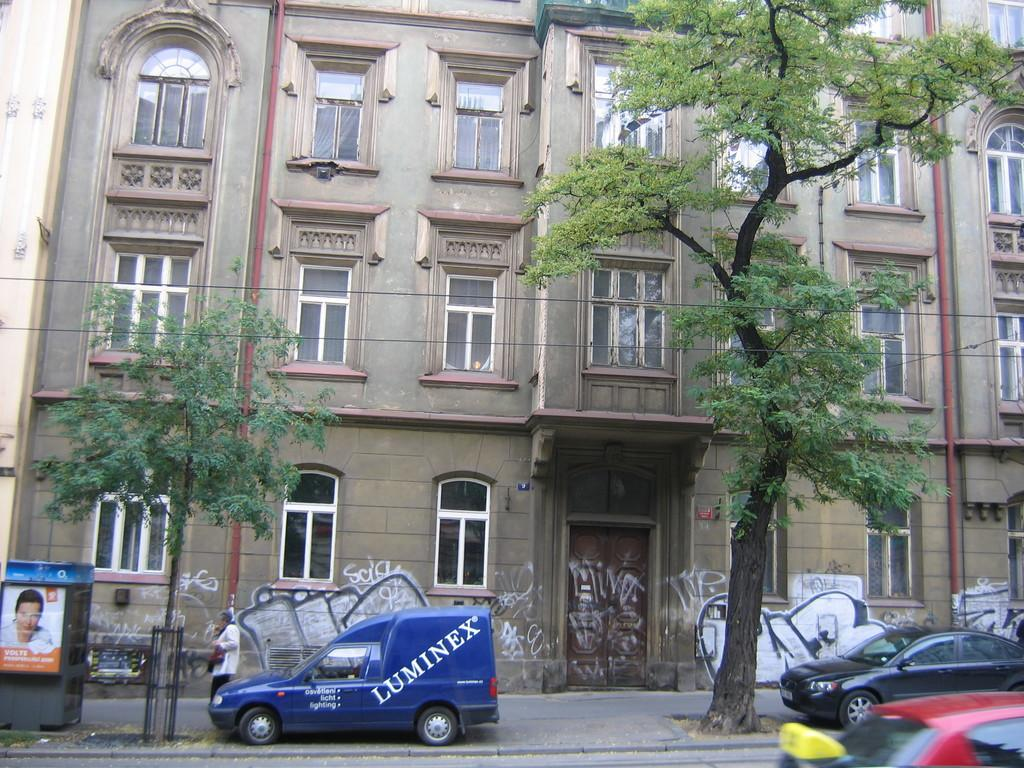What is the person in the image doing? There is a person walking on the pathway in the image. What else can be seen on the ground in the image? There are vehicles on the road in the image. What type of natural elements are present in the image? There are trees in the image. What else can be seen in the air in the image? Cables are visible in the image. What type of man-made structure is present in the image? There is a building in the image. Where is the kitten playing with the selection of toys in the image? There is no kitten or toys present in the image. What type of light is shining on the building in the image? The provided facts do not mention any specific type of light shining on the building in the image. 